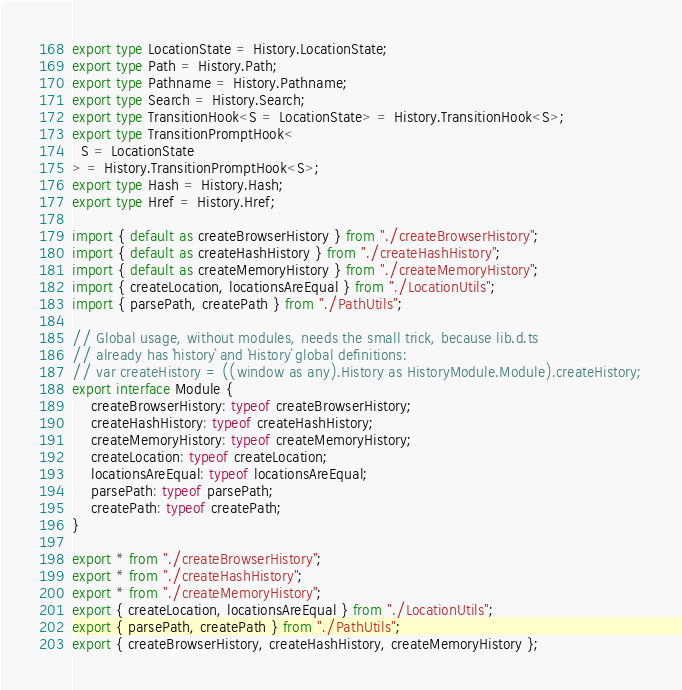<code> <loc_0><loc_0><loc_500><loc_500><_TypeScript_>export type LocationState = History.LocationState;
export type Path = History.Path;
export type Pathname = History.Pathname;
export type Search = History.Search;
export type TransitionHook<S = LocationState> = History.TransitionHook<S>;
export type TransitionPromptHook<
  S = LocationState
> = History.TransitionPromptHook<S>;
export type Hash = History.Hash;
export type Href = History.Href;

import { default as createBrowserHistory } from "./createBrowserHistory";
import { default as createHashHistory } from "./createHashHistory";
import { default as createMemoryHistory } from "./createMemoryHistory";
import { createLocation, locationsAreEqual } from "./LocationUtils";
import { parsePath, createPath } from "./PathUtils";

// Global usage, without modules, needs the small trick, because lib.d.ts
// already has `history` and `History` global definitions:
// var createHistory = ((window as any).History as HistoryModule.Module).createHistory;
export interface Module {
    createBrowserHistory: typeof createBrowserHistory;
    createHashHistory: typeof createHashHistory;
    createMemoryHistory: typeof createMemoryHistory;
    createLocation: typeof createLocation;
    locationsAreEqual: typeof locationsAreEqual;
    parsePath: typeof parsePath;
    createPath: typeof createPath;
}

export * from "./createBrowserHistory";
export * from "./createHashHistory";
export * from "./createMemoryHistory";
export { createLocation, locationsAreEqual } from "./LocationUtils";
export { parsePath, createPath } from "./PathUtils";
export { createBrowserHistory, createHashHistory, createMemoryHistory };
</code> 